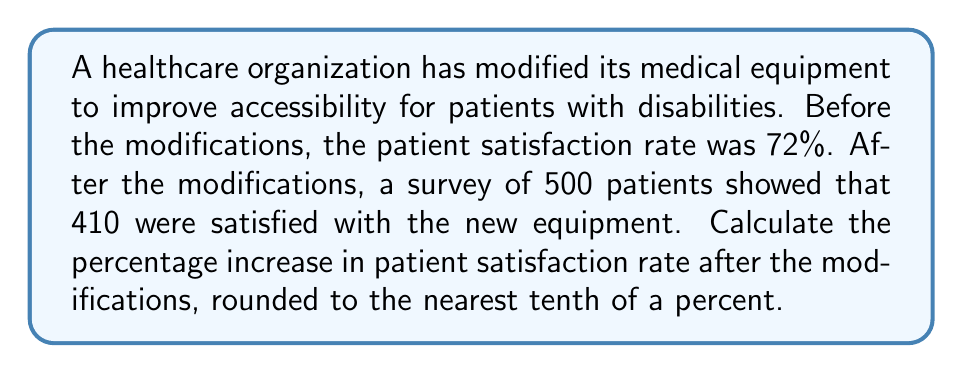Could you help me with this problem? To solve this problem, we'll follow these steps:

1. Calculate the new satisfaction rate after modifications:
   $$ \text{New satisfaction rate} = \frac{\text{Number of satisfied patients}}{\text{Total number of patients surveyed}} \times 100\% $$
   $$ = \frac{410}{500} \times 100\% = 82\% $$

2. Calculate the difference between the new and old satisfaction rates:
   $$ \text{Difference} = \text{New rate} - \text{Old rate} $$
   $$ = 82\% - 72\% = 10\% $$

3. Calculate the percentage increase:
   $$ \text{Percentage increase} = \frac{\text{Difference}}{\text{Old rate}} \times 100\% $$
   $$ = \frac{10\%}{72\%} \times 100\% $$
   $$ = 0.1388888889 \times 100\% $$
   $$ = 13.88888889\% $$

4. Round to the nearest tenth of a percent:
   $$ 13.9\% $$
Answer: The percentage increase in patient satisfaction rate after the equipment modifications is 13.9%. 